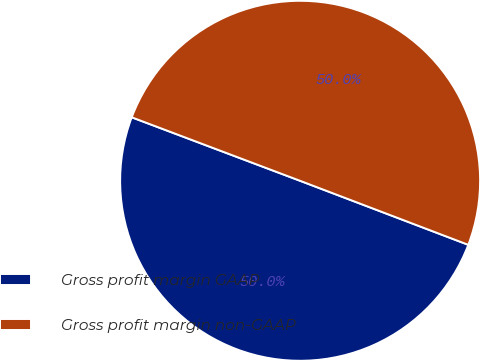Convert chart to OTSL. <chart><loc_0><loc_0><loc_500><loc_500><pie_chart><fcel>Gross profit margin GAAP<fcel>Gross profit margin non-GAAP<nl><fcel>49.95%<fcel>50.05%<nl></chart> 